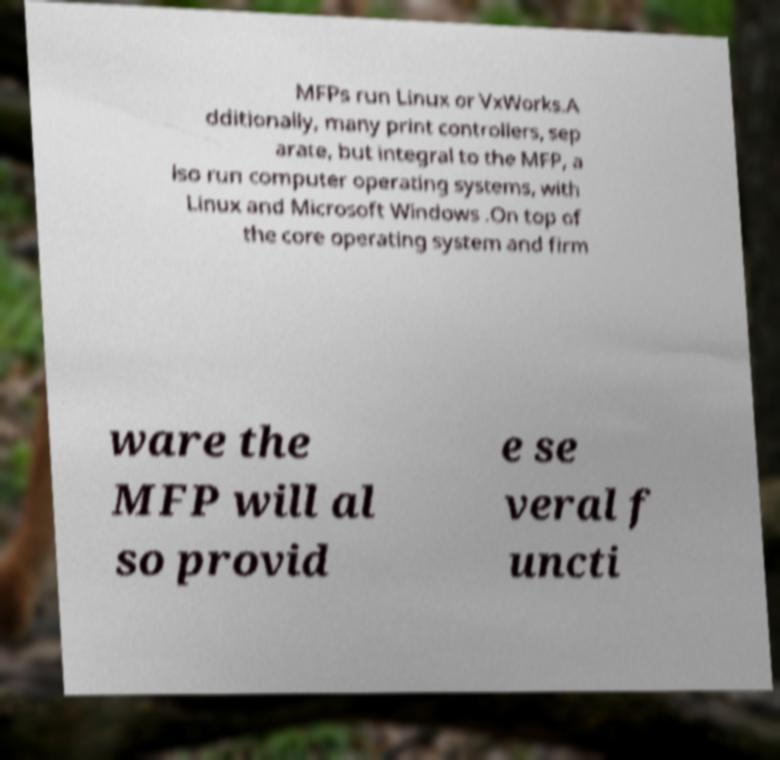I need the written content from this picture converted into text. Can you do that? MFPs run Linux or VxWorks.A dditionally, many print controllers, sep arate, but integral to the MFP, a lso run computer operating systems, with Linux and Microsoft Windows .On top of the core operating system and firm ware the MFP will al so provid e se veral f uncti 